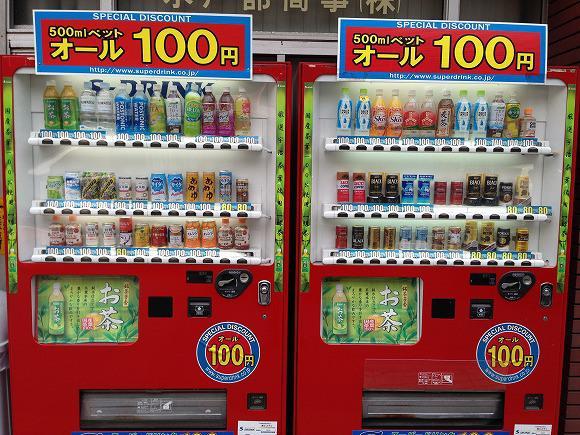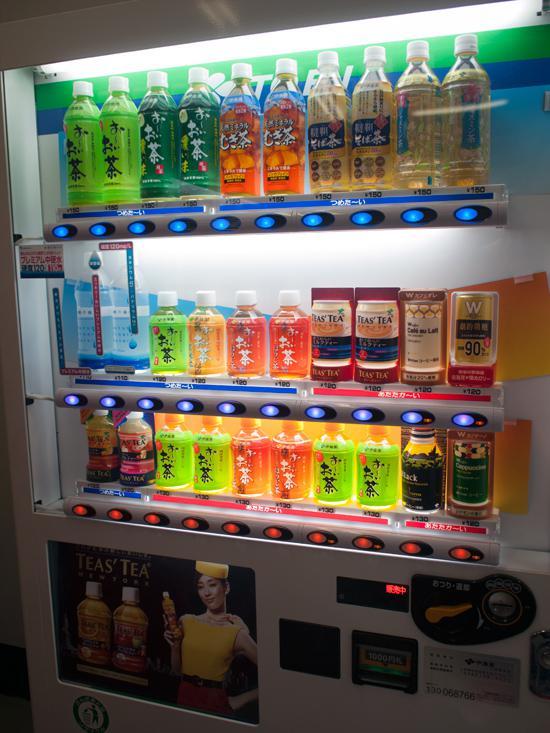The first image is the image on the left, the second image is the image on the right. For the images displayed, is the sentence "The wall against which the vending machine is placed can be seen in one of the images." factually correct? Answer yes or no. Yes. The first image is the image on the left, the second image is the image on the right. Examine the images to the left and right. Is the description "At least one vending machine has a background with bright blue predominant." accurate? Answer yes or no. No. 